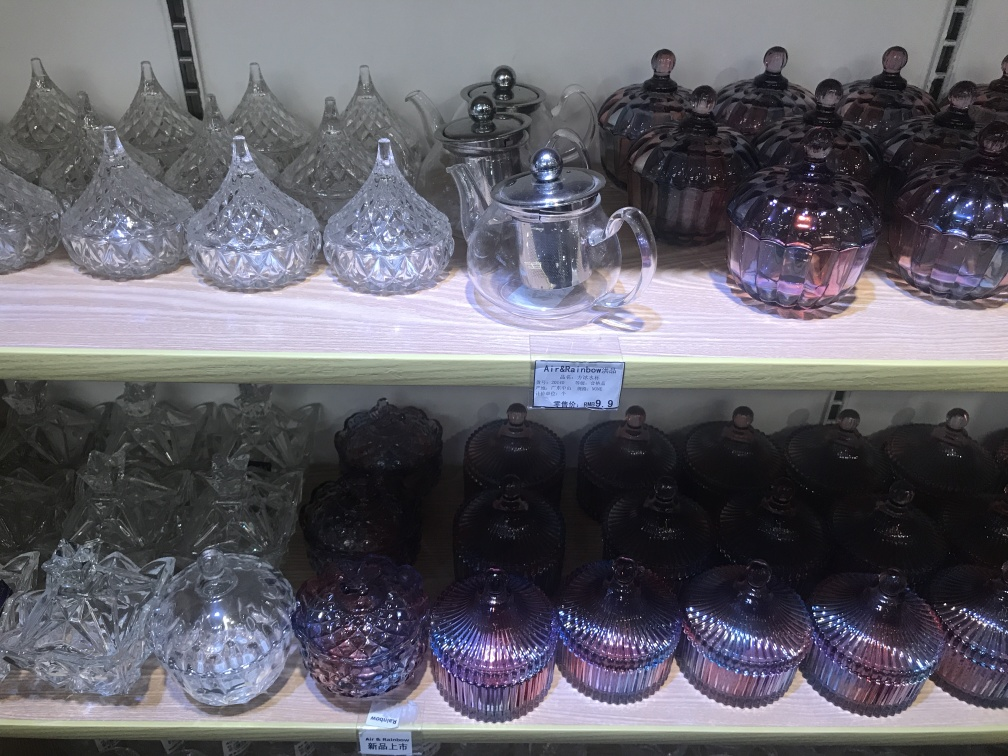Does the teapot retain most of the texture details? Indeed, the teapot in the image showcases a clear and distinct texture characterized by its diamond-patterned glass design that reflects light beautifully. This texture is integral to its aesthetic appeal and is well-preserved, which suggests it's likely of good craftsmanship. The intricacies of the design are visible, and there are no evident distortions or blemishes that obscure the detailing. 